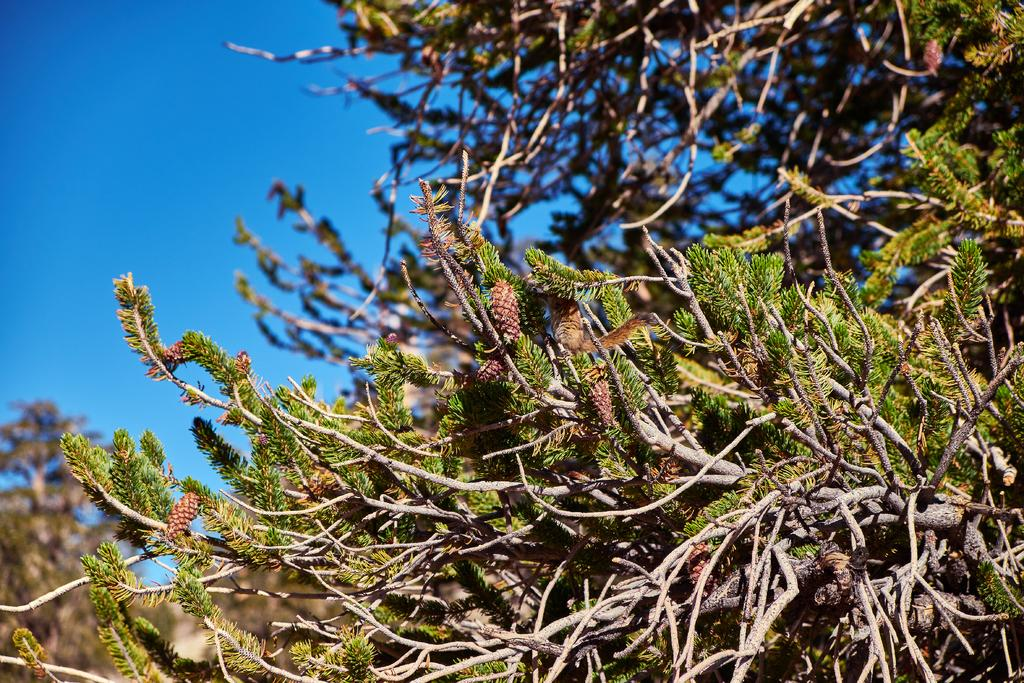What type of vegetation is present in the image? There are trees in the image. What can be observed about the trees in the image? The trees have leaves and fruits. What animal can be seen in the image? A squirrel is sitting on the branches of a tree. What is visible in the background of the image? The sky is visible in the background of the image. What type of pen can be seen in the image? There is no pen present in the image. Is the moon visible in the image? The moon is not visible in the image; only the sky is visible in the background. 